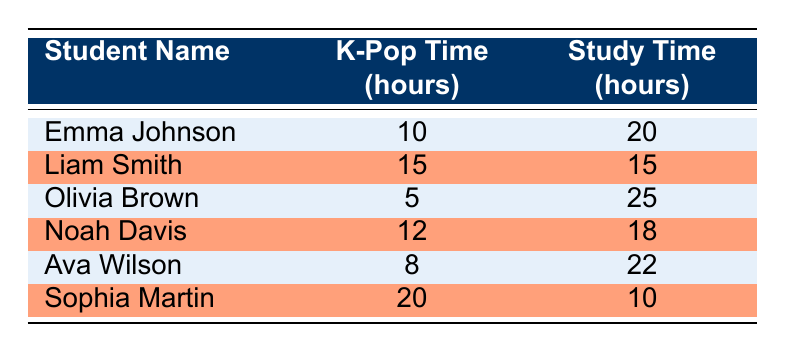What is the K-Pop time for Olivia Brown? Olivia Brown's K-Pop time is listed in the table as 5 hours.
Answer: 5 What is the study time of Liam Smith? The table indicates that Liam Smith has a study time of 15 hours.
Answer: 15 Which student spends the most time on K-Pop-related activities? Sophia Martin spends the most time on K-Pop-related activities, at 20 hours, which is more than any other student listed.
Answer: Sophia Martin What is the combined total of K-Pop and study time for Noah Davis? Noah Davis spends 12 hours on K-Pop and 18 hours studying. Combining these gives us 12 + 18 = 30 hours.
Answer: 30 Is it true that Ava Wilson spends more time studying than doing K-Pop activities? Yes, Ava Wilson's study time is 22 hours, which is greater than her 8 hours of K-Pop time, confirming that she indeed spends more time studying.
Answer: Yes What is the average K-Pop time across all students? To find the average, we first sum the K-Pop time: 10 + 15 + 5 + 12 + 8 + 20 = 70 hours. There are 6 students, so the average is 70 / 6 ≈ 11.67 hours.
Answer: Approximately 11.67 Which student has the least study time? By comparing the study times, Sophia Martin has the least, spending just 10 hours on studying.
Answer: Sophia Martin Is the study time for Emma Johnson greater than the average K-Pop time? First, we determined the average K-Pop time as approximately 11.67 hours. Emma Johnson's study time is 20 hours, which is indeed greater than the average K-Pop time, so the statement is true.
Answer: Yes What is the difference between the K-Pop time and study time for each student? For Emma Johnson, the difference is 20 - 10 = 10; for Liam Smith, it’s 15 - 15 = 0; for Olivia Brown, it’s 25 - 5 = 20; for Noah Davis, it’s 18 - 12 = 6; for Ava Wilson, it’s 22 - 8 = 14; for Sophia Martin, it’s 10 - 20 = -10.
Answer: Differences: 10, 0, 20, 6, 14, -10 